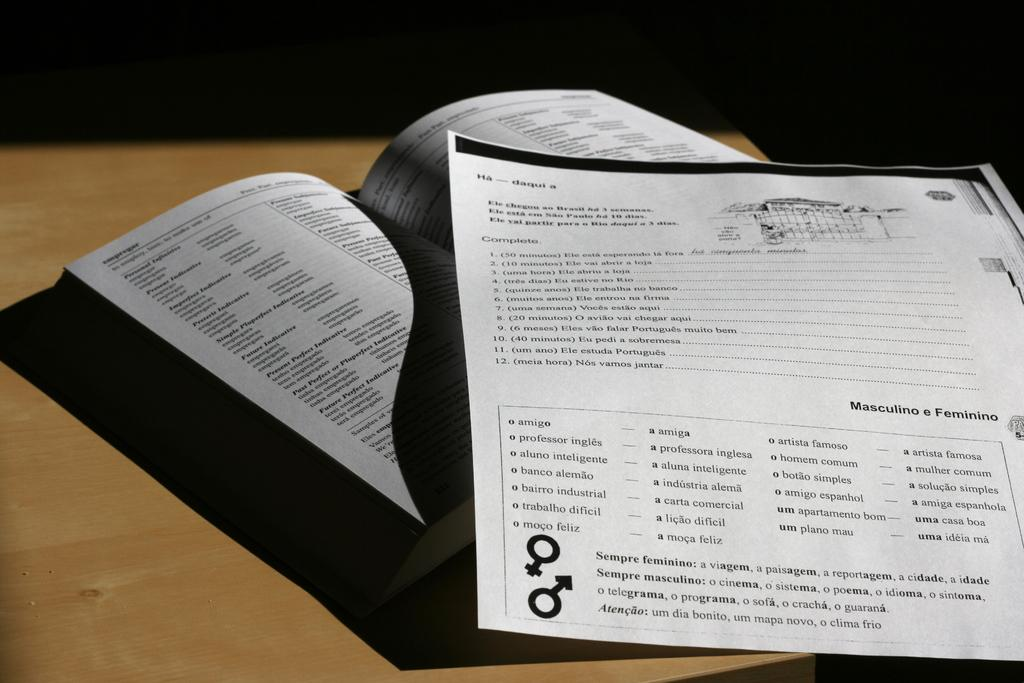Provide a one-sentence caption for the provided image. DOUCUMENT PAPER PLACED ON TOP OF THE PAGES OF AN OPEN BOOK. 